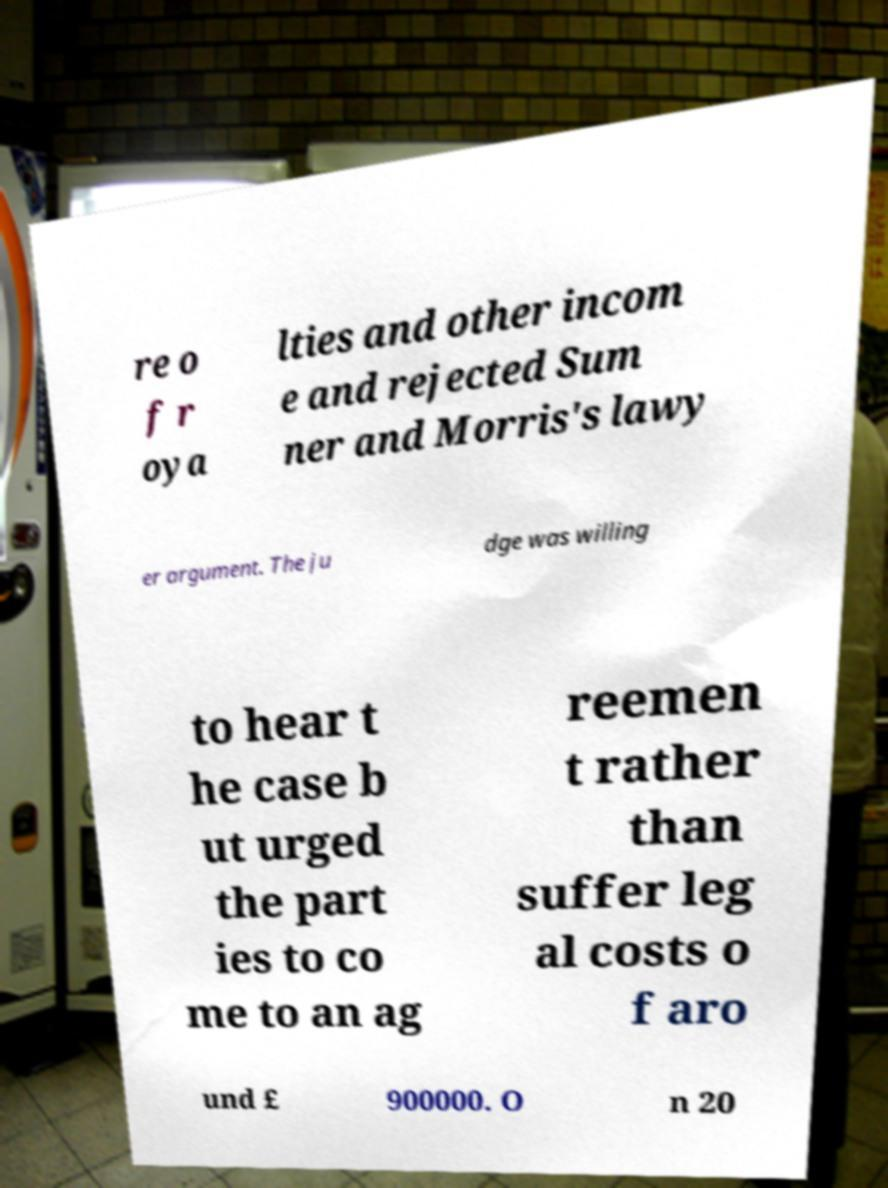Could you extract and type out the text from this image? re o f r oya lties and other incom e and rejected Sum ner and Morris's lawy er argument. The ju dge was willing to hear t he case b ut urged the part ies to co me to an ag reemen t rather than suffer leg al costs o f aro und £ 900000. O n 20 